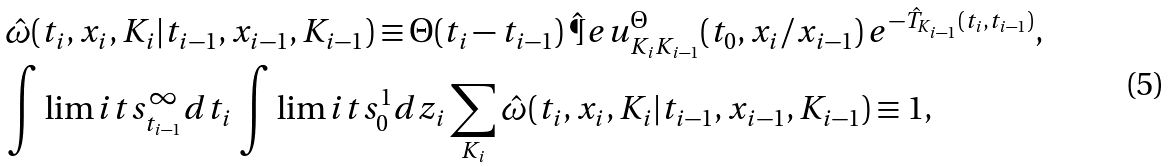<formula> <loc_0><loc_0><loc_500><loc_500>& \hat { \omega } ( t _ { i } , x _ { i } , K _ { i } | t _ { i - 1 } , x _ { i - 1 } , K _ { i - 1 } ) \equiv \Theta ( t _ { i } - t _ { i - 1 } ) \, \hat { \P } e u _ { K _ { i } K _ { i - 1 } } ^ { \Theta } ( t _ { 0 } , x _ { i } / x _ { i - 1 } ) \, e ^ { - \hat { T } _ { K _ { i - 1 } } ( t _ { i } , t _ { i - 1 } ) } , \\ & \int \lim i t s _ { t _ { i - 1 } } ^ { \infty } d t _ { i } \, \int \lim i t s _ { 0 } ^ { 1 } d z _ { i } \sum _ { K _ { i } } \hat { \omega } ( t _ { i } , x _ { i } , K _ { i } | t _ { i - 1 } , x _ { i - 1 } , K _ { i - 1 } ) \equiv 1 ,</formula> 